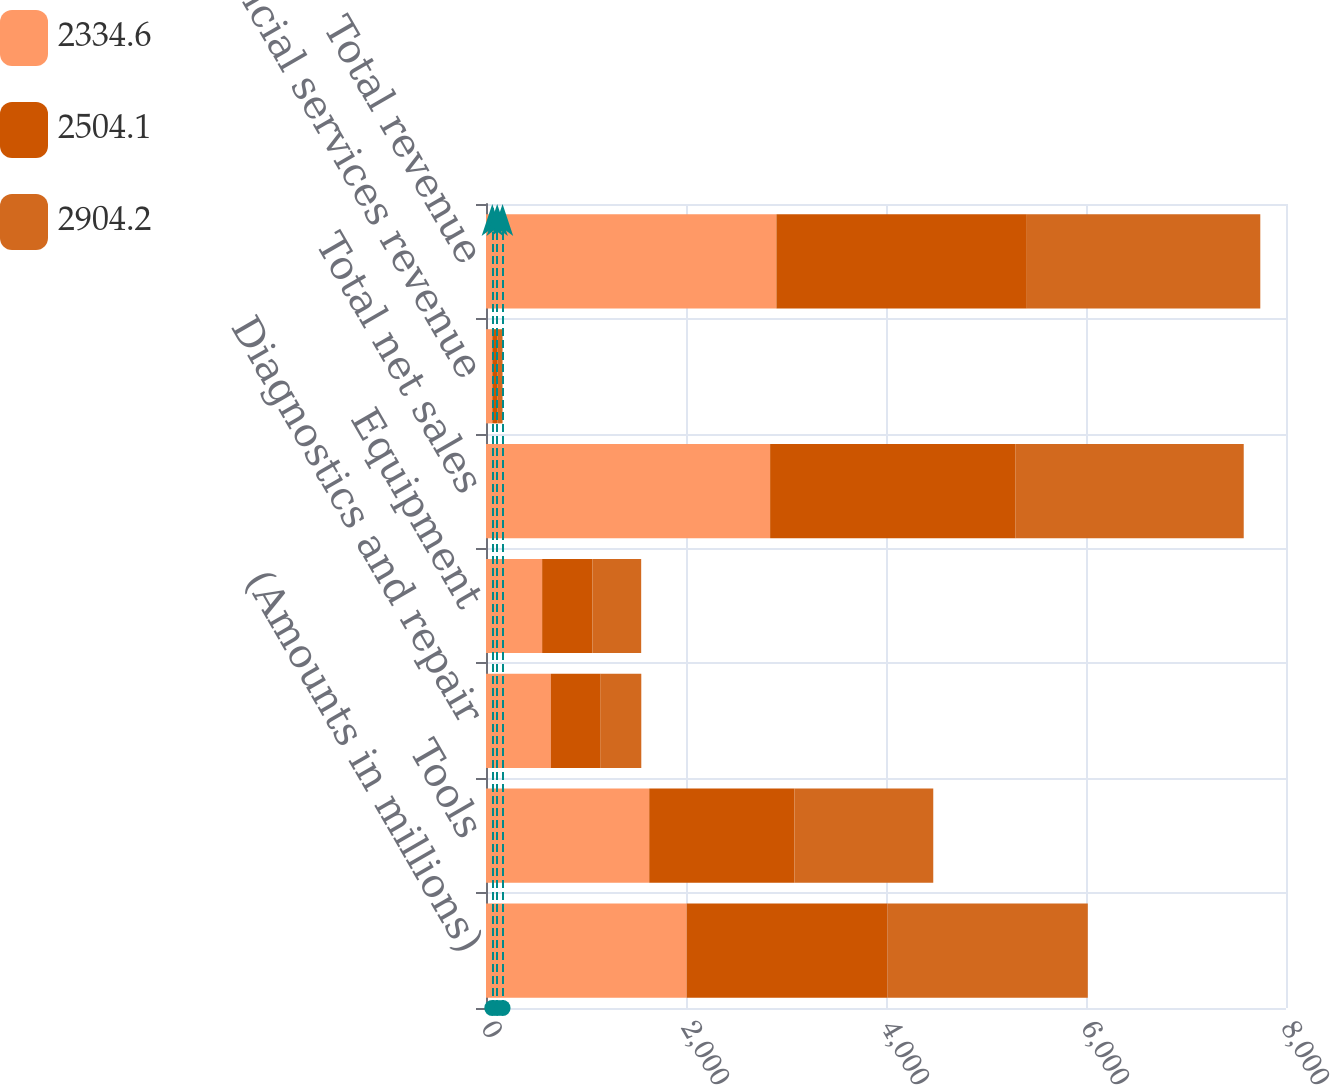Convert chart. <chart><loc_0><loc_0><loc_500><loc_500><stacked_bar_chart><ecel><fcel>(Amounts in millions)<fcel>Tools<fcel>Diagnostics and repair<fcel>Equipment<fcel>Total net sales<fcel>Financial services revenue<fcel>Total revenue<nl><fcel>2334.6<fcel>2007<fcel>1632.2<fcel>647.6<fcel>561.4<fcel>2841.2<fcel>63<fcel>2904.2<nl><fcel>2504.1<fcel>2006<fcel>1453.1<fcel>499.5<fcel>502.5<fcel>2455.1<fcel>49<fcel>2504.1<nl><fcel>2904.2<fcel>2005<fcel>1387.3<fcel>405.8<fcel>487.9<fcel>2281<fcel>53.6<fcel>2334.6<nl></chart> 